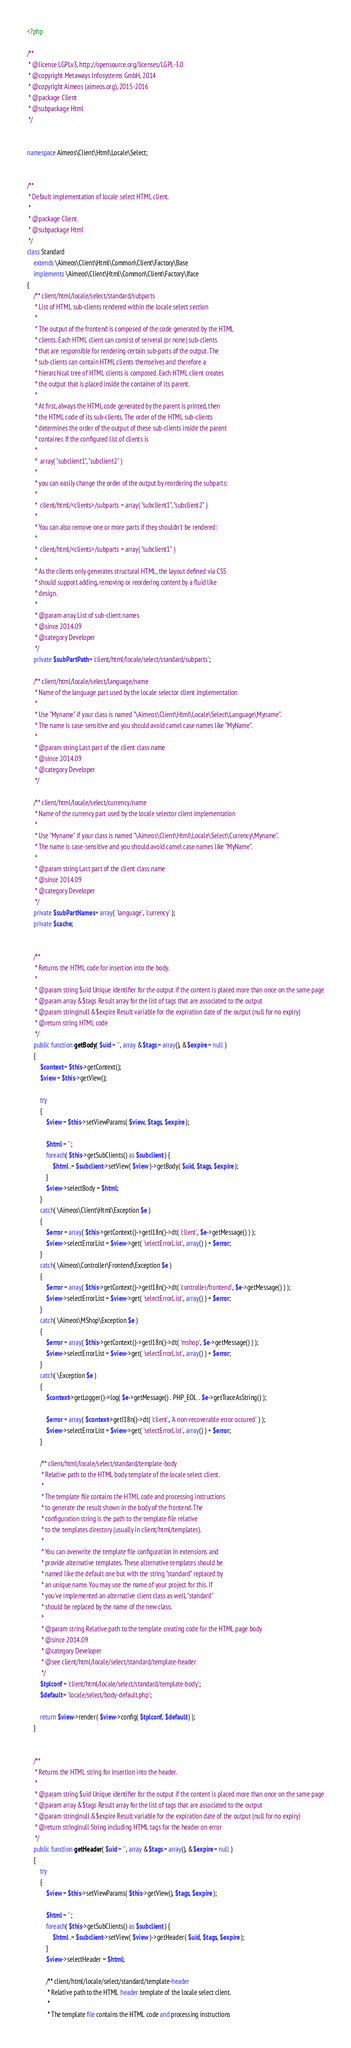Convert code to text. <code><loc_0><loc_0><loc_500><loc_500><_PHP_><?php

/**
 * @license LGPLv3, http://opensource.org/licenses/LGPL-3.0
 * @copyright Metaways Infosystems GmbH, 2014
 * @copyright Aimeos (aimeos.org), 2015-2016
 * @package Client
 * @subpackage Html
 */


namespace Aimeos\Client\Html\Locale\Select;


/**
 * Default implementation of locale select HTML client.
 *
 * @package Client
 * @subpackage Html
 */
class Standard
	extends \Aimeos\Client\Html\Common\Client\Factory\Base
	implements \Aimeos\Client\Html\Common\Client\Factory\Iface
{
	/** client/html/locale/select/standard/subparts
	 * List of HTML sub-clients rendered within the locale select section
	 *
	 * The output of the frontend is composed of the code generated by the HTML
	 * clients. Each HTML client can consist of serveral (or none) sub-clients
	 * that are responsible for rendering certain sub-parts of the output. The
	 * sub-clients can contain HTML clients themselves and therefore a
	 * hierarchical tree of HTML clients is composed. Each HTML client creates
	 * the output that is placed inside the container of its parent.
	 *
	 * At first, always the HTML code generated by the parent is printed, then
	 * the HTML code of its sub-clients. The order of the HTML sub-clients
	 * determines the order of the output of these sub-clients inside the parent
	 * container. If the configured list of clients is
	 *
	 *  array( "subclient1", "subclient2" )
	 *
	 * you can easily change the order of the output by reordering the subparts:
	 *
	 *  client/html/<clients>/subparts = array( "subclient1", "subclient2" )
	 *
	 * You can also remove one or more parts if they shouldn't be rendered:
	 *
	 *  client/html/<clients>/subparts = array( "subclient1" )
	 *
	 * As the clients only generates structural HTML, the layout defined via CSS
	 * should support adding, removing or reordering content by a fluid like
	 * design.
	 *
	 * @param array List of sub-client names
	 * @since 2014.09
	 * @category Developer
	 */
	private $subPartPath = 'client/html/locale/select/standard/subparts';

	/** client/html/locale/select/language/name
	 * Name of the language part used by the locale selector client implementation
	 *
	 * Use "Myname" if your class is named "\Aimeos\Client\Html\Locale\Select\Language\Myname".
	 * The name is case-sensitive and you should avoid camel case names like "MyName".
	 *
	 * @param string Last part of the client class name
	 * @since 2014.09
	 * @category Developer
	 */

	/** client/html/locale/select/currency/name
	 * Name of the currency part used by the locale selector client implementation
	 *
	 * Use "Myname" if your class is named "\Aimeos\Client\Html\Locale\Select\Currency\Myname".
	 * The name is case-sensitive and you should avoid camel case names like "MyName".
	 *
	 * @param string Last part of the client class name
	 * @since 2014.09
	 * @category Developer
	 */
	private $subPartNames = array( 'language', 'currency' );
	private $cache;


	/**
	 * Returns the HTML code for insertion into the body.
	 *
	 * @param string $uid Unique identifier for the output if the content is placed more than once on the same page
	 * @param array &$tags Result array for the list of tags that are associated to the output
	 * @param string|null &$expire Result variable for the expiration date of the output (null for no expiry)
	 * @return string HTML code
	 */
	public function getBody( $uid = '', array &$tags = array(), &$expire = null )
	{
		$context = $this->getContext();
		$view = $this->getView();

		try
		{
			$view = $this->setViewParams( $view, $tags, $expire );

			$html = '';
			foreach( $this->getSubClients() as $subclient ) {
				$html .= $subclient->setView( $view )->getBody( $uid, $tags, $expire );
			}
			$view->selectBody = $html;
		}
		catch( \Aimeos\Client\Html\Exception $e )
		{
			$error = array( $this->getContext()->getI18n()->dt( 'client', $e->getMessage() ) );
			$view->selectErrorList = $view->get( 'selectErrorList', array() ) + $error;
		}
		catch( \Aimeos\Controller\Frontend\Exception $e )
		{
			$error = array( $this->getContext()->getI18n()->dt( 'controller/frontend', $e->getMessage() ) );
			$view->selectErrorList = $view->get( 'selectErrorList', array() ) + $error;
		}
		catch( \Aimeos\MShop\Exception $e )
		{
			$error = array( $this->getContext()->getI18n()->dt( 'mshop', $e->getMessage() ) );
			$view->selectErrorList = $view->get( 'selectErrorList', array() ) + $error;
		}
		catch( \Exception $e )
		{
			$context->getLogger()->log( $e->getMessage() . PHP_EOL . $e->getTraceAsString() );

			$error = array( $context->getI18n()->dt( 'client', 'A non-recoverable error occured' ) );
			$view->selectErrorList = $view->get( 'selectErrorList', array() ) + $error;
		}

		/** client/html/locale/select/standard/template-body
		 * Relative path to the HTML body template of the locale select client.
		 *
		 * The template file contains the HTML code and processing instructions
		 * to generate the result shown in the body of the frontend. The
		 * configuration string is the path to the template file relative
		 * to the templates directory (usually in client/html/templates).
		 *
		 * You can overwrite the template file configuration in extensions and
		 * provide alternative templates. These alternative templates should be
		 * named like the default one but with the string "standard" replaced by
		 * an unique name. You may use the name of your project for this. If
		 * you've implemented an alternative client class as well, "standard"
		 * should be replaced by the name of the new class.
		 *
		 * @param string Relative path to the template creating code for the HTML page body
		 * @since 2014.09
		 * @category Developer
		 * @see client/html/locale/select/standard/template-header
		 */
		$tplconf = 'client/html/locale/select/standard/template-body';
		$default = 'locale/select/body-default.php';

		return $view->render( $view->config( $tplconf, $default ) );
	}


	/**
	 * Returns the HTML string for insertion into the header.
	 *
	 * @param string $uid Unique identifier for the output if the content is placed more than once on the same page
	 * @param array &$tags Result array for the list of tags that are associated to the output
	 * @param string|null &$expire Result variable for the expiration date of the output (null for no expiry)
	 * @return string|null String including HTML tags for the header on error
	 */
	public function getHeader( $uid = '', array &$tags = array(), &$expire = null )
	{
		try
		{
			$view = $this->setViewParams( $this->getView(), $tags, $expire );

			$html = '';
			foreach( $this->getSubClients() as $subclient ) {
				$html .= $subclient->setView( $view )->getHeader( $uid, $tags, $expire );
			}
			$view->selectHeader = $html;

			/** client/html/locale/select/standard/template-header
			 * Relative path to the HTML header template of the locale select client.
			 *
			 * The template file contains the HTML code and processing instructions</code> 